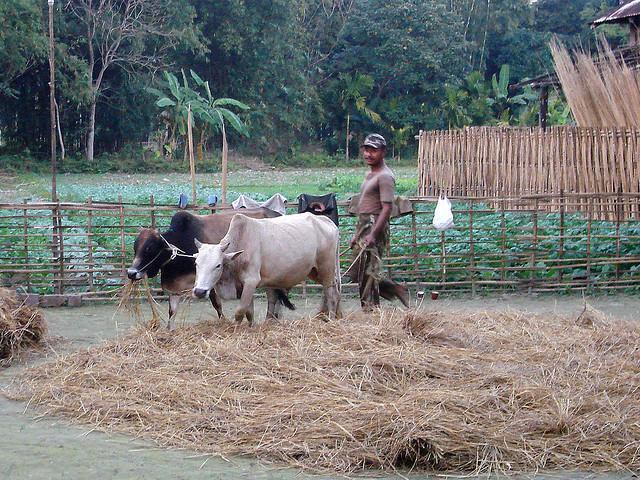What diet are the cows here on?
Indicate the correct response and explain using: 'Answer: answer
Rationale: rationale.'
Options: Vegan, carnivorous, milk, fasting. Answer: vegan.
Rationale: Cows are grazing in a pen. What keeps the cattle from eating the garden here?
Choose the correct response and explain in the format: 'Answer: answer
Rationale: rationale.'
Options: Man, fencing, nothing, fear. Answer: fencing.
Rationale: Fencing has been erected between the garden and the cattle, which will theoretically keep hungry animals at bay. they seem to be enjoying their hay, meanwhile. 